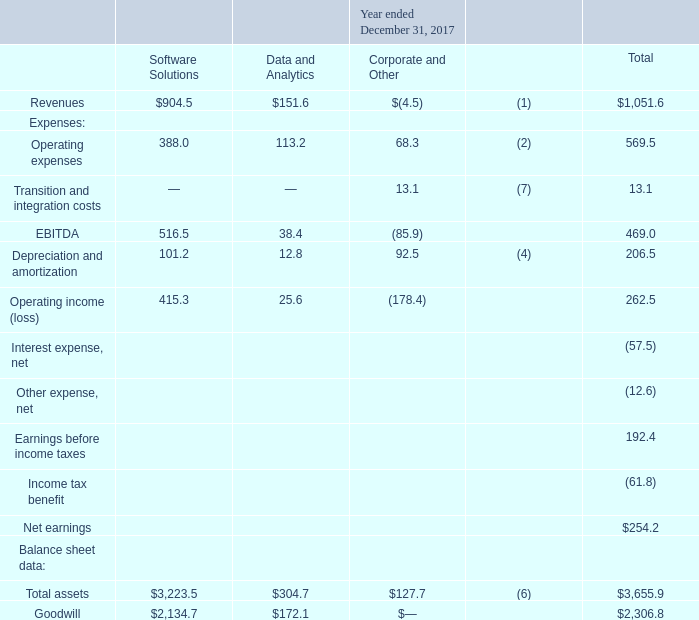Summarized financial information concerning our segments is shown in the tables below (in millions):
(1) Revenues for Corporate and Other represent deferred revenue purchase accounting adjustments recorded in accordance with GAAP
(2) Operating expenses for Corporate and Other includes equity-based compensation, including certain related payroll taxes, of $51.7 million, $51.4 million and $19.2 million for the years ended December 31, 2019, 2018 and 2017, respectively.
(4) Depreciation and amortization for Corporate and Other primarily represents net incremental depreciation and amortization adjustments associated with the application of purchase accounting recorded in accordance with GAAP.
(6) Receivables from related parties are included in Corporate and Other.
(7) Transition and integration costs primarily consists of legal and professional fees related to the Distribution and transition-related costs following the Distribution.
What did operating expenses for Corporate and Other include? Equity-based compensation, including certain related payroll taxes. Where was receivables from related parties included in? Corporate and other. What was the total amount of Goodwill?
Answer scale should be: million. 2,306.8. Which expenses had a total that exceeded $100 million? (Operating expenses:569.5)
Answer: operating expenses. What was the difference between the total assets and goodwill from data and analytics?
Answer scale should be: million. 304.7-172.1
Answer: 132.6. What was the difference between Operating expenses and Revenues from Software Solutions?
Answer scale should be: million. 904.5-388.0
Answer: 516.5. 